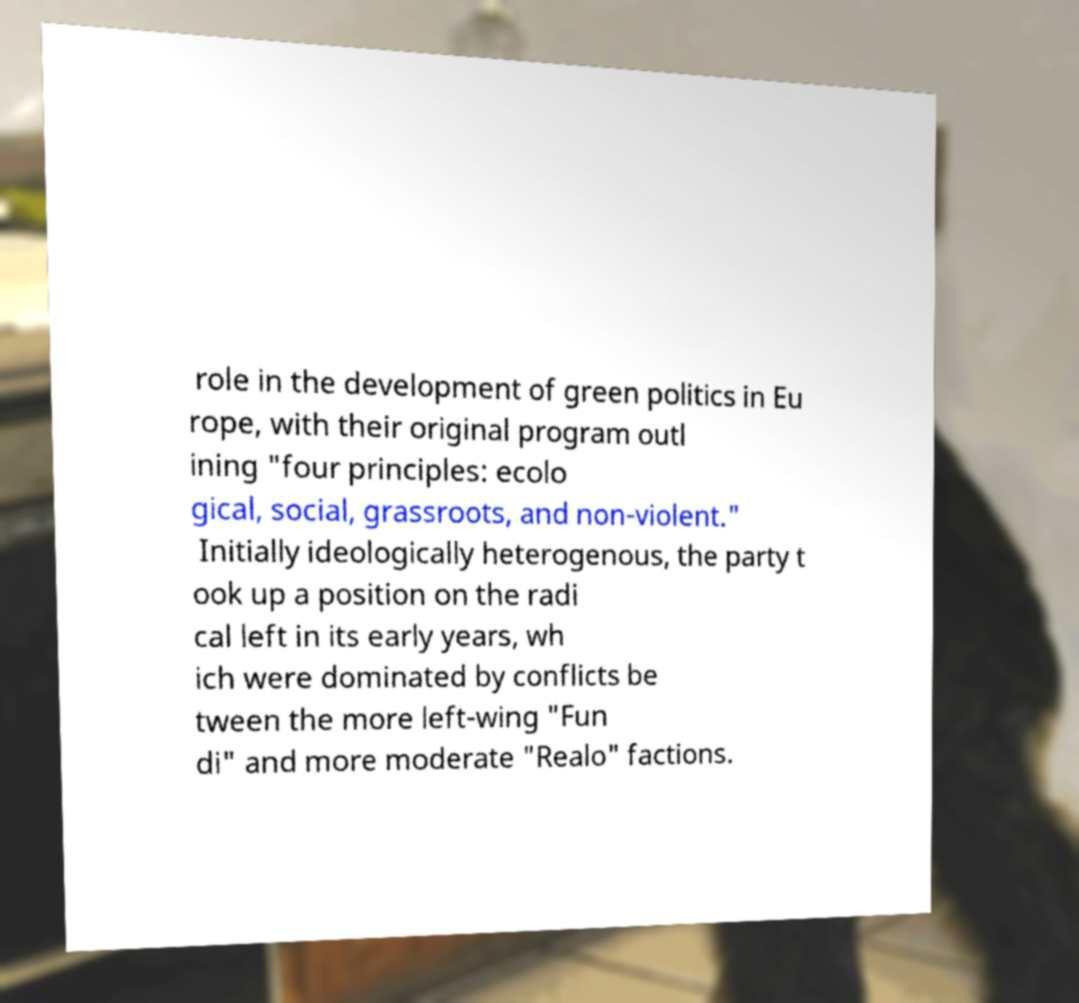Can you read and provide the text displayed in the image?This photo seems to have some interesting text. Can you extract and type it out for me? role in the development of green politics in Eu rope, with their original program outl ining "four principles: ecolo gical, social, grassroots, and non-violent." Initially ideologically heterogenous, the party t ook up a position on the radi cal left in its early years, wh ich were dominated by conflicts be tween the more left-wing "Fun di" and more moderate "Realo" factions. 